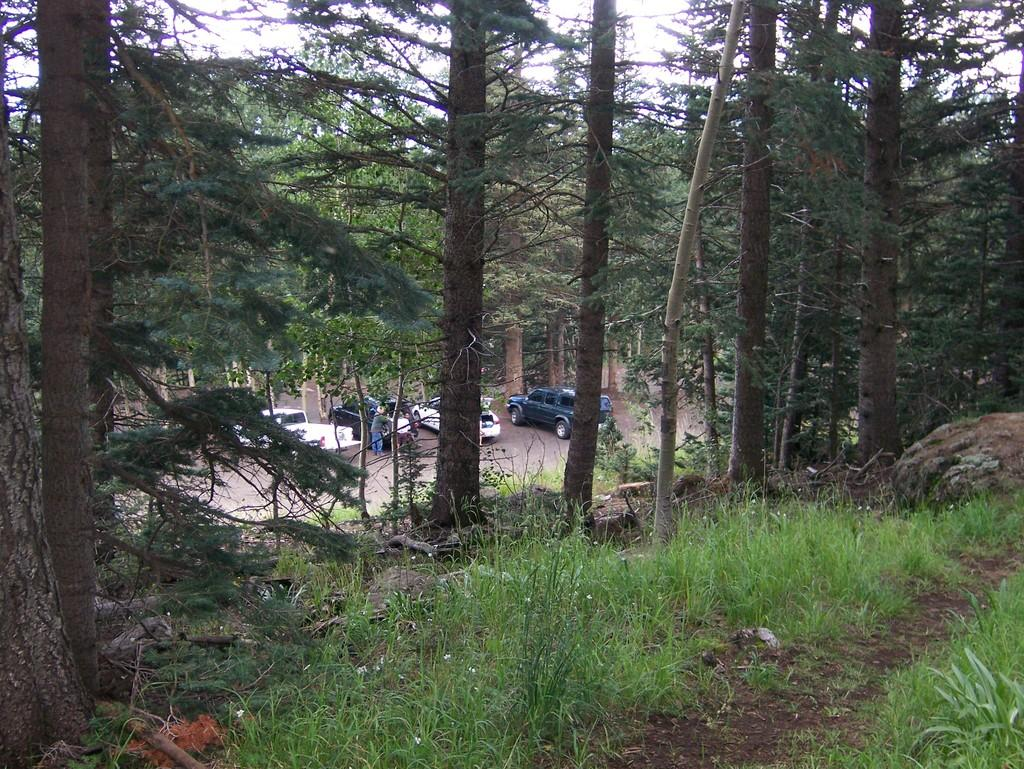What types of objects can be seen in the image? There are vehicles and persons on the road in the image. What natural elements are present in the image? There are trees, plants, grass, and the sky visible in the image. Can you describe the setting of the image? The image features a road with vehicles and persons, surrounded by trees, plants, and grass, with the sky visible above. What type of amusement can be seen in the image? There is no amusement present in the image; it features a road with vehicles and persons, surrounded by trees, plants, and grass, with the sky visible above. What kind of drum is being played in the image? There is no drum present in the image. 